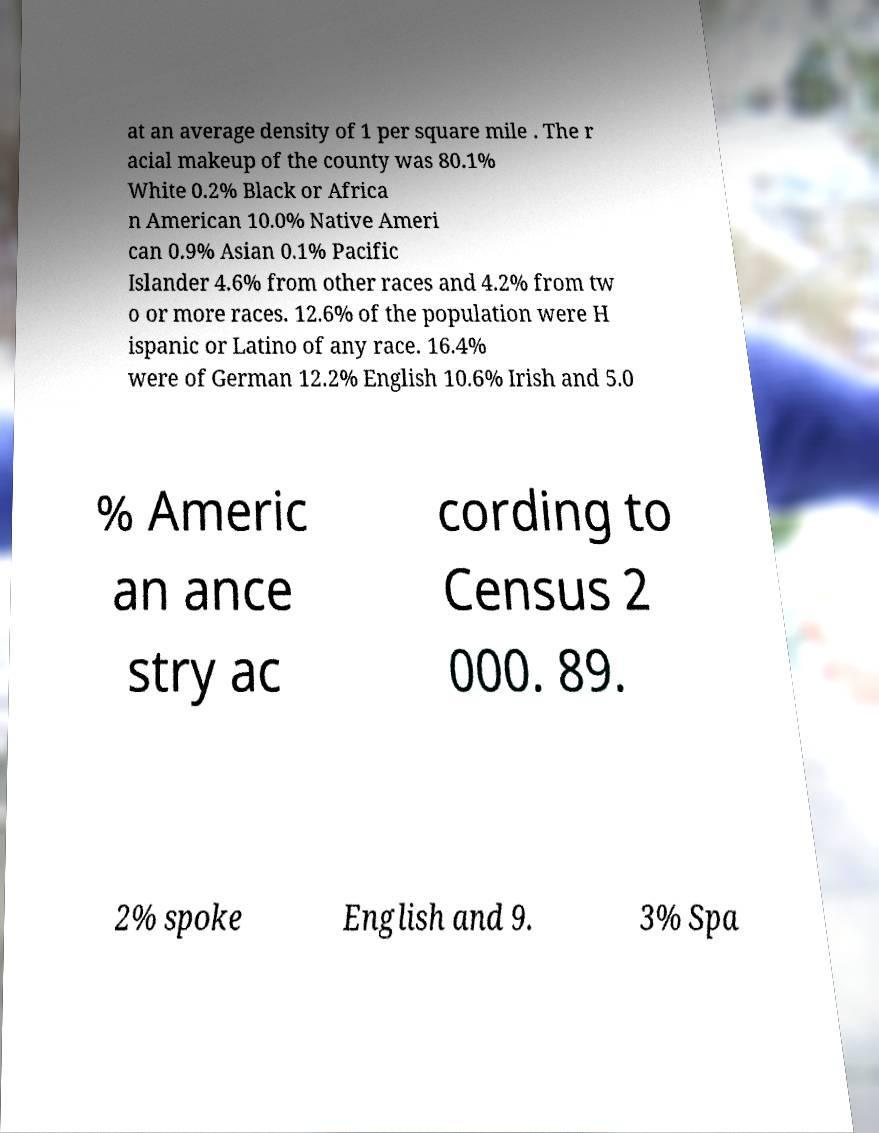For documentation purposes, I need the text within this image transcribed. Could you provide that? at an average density of 1 per square mile . The r acial makeup of the county was 80.1% White 0.2% Black or Africa n American 10.0% Native Ameri can 0.9% Asian 0.1% Pacific Islander 4.6% from other races and 4.2% from tw o or more races. 12.6% of the population were H ispanic or Latino of any race. 16.4% were of German 12.2% English 10.6% Irish and 5.0 % Americ an ance stry ac cording to Census 2 000. 89. 2% spoke English and 9. 3% Spa 